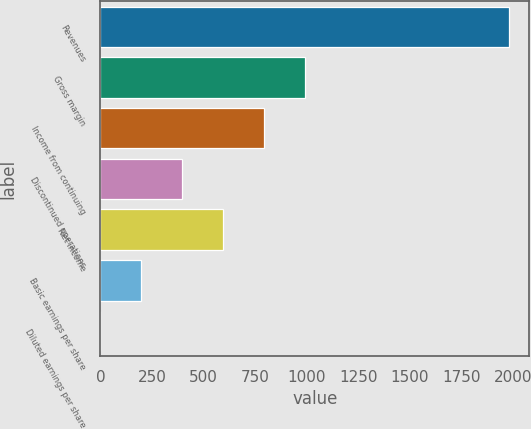Convert chart. <chart><loc_0><loc_0><loc_500><loc_500><bar_chart><fcel>Revenues<fcel>Gross margin<fcel>Income from continuing<fcel>Discontinued operations<fcel>Net income<fcel>Basic earnings per share<fcel>Diluted earnings per share<nl><fcel>1981<fcel>990.67<fcel>792.6<fcel>396.46<fcel>594.53<fcel>198.39<fcel>0.32<nl></chart> 